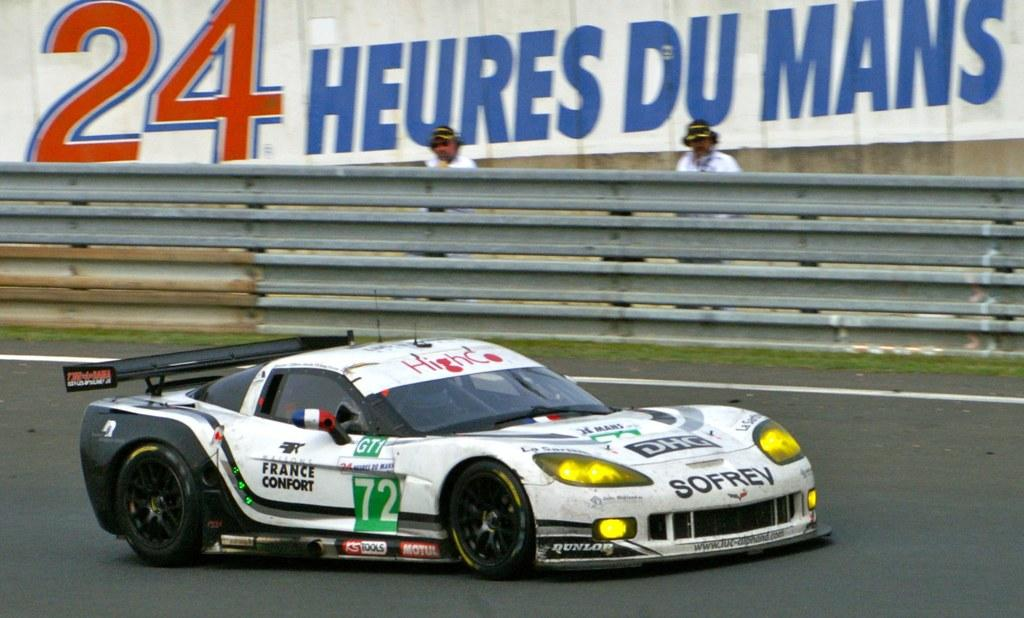What type of vehicle is in the image? There is a sports car in the image. What color is the sports car? The sports car is white. Where is the sports car located? The sports car is on the road. What can be seen in the middle of the image? There is an iron fence in the middle of the image. How many people are in the image? Two men are standing in the image. What is on the wall at the top of the image? There is an advertisement on a wall at the top of the image. What type of flower is growing on the sports car in the image? There are no flowers present on the sports car in the image. 